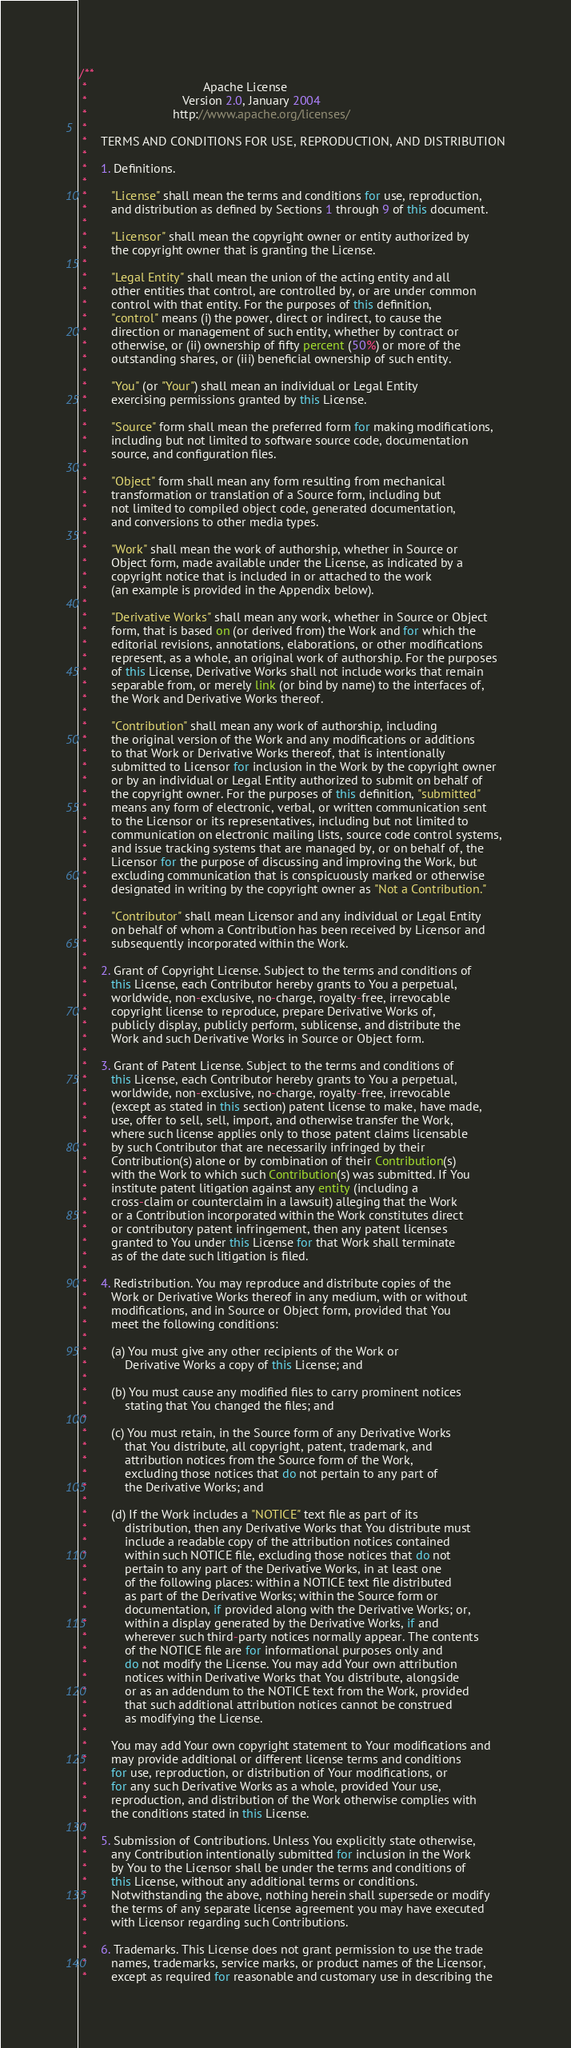Convert code to text. <code><loc_0><loc_0><loc_500><loc_500><_Java_>/**
 *                                  Apache License
 *                            Version 2.0, January 2004
 *                         http://www.apache.org/licenses/
 *
 *    TERMS AND CONDITIONS FOR USE, REPRODUCTION, AND DISTRIBUTION
 *
 *    1. Definitions.
 *
 *       "License" shall mean the terms and conditions for use, reproduction,
 *       and distribution as defined by Sections 1 through 9 of this document.
 *
 *       "Licensor" shall mean the copyright owner or entity authorized by
 *       the copyright owner that is granting the License.
 *
 *       "Legal Entity" shall mean the union of the acting entity and all
 *       other entities that control, are controlled by, or are under common
 *       control with that entity. For the purposes of this definition,
 *       "control" means (i) the power, direct or indirect, to cause the
 *       direction or management of such entity, whether by contract or
 *       otherwise, or (ii) ownership of fifty percent (50%) or more of the
 *       outstanding shares, or (iii) beneficial ownership of such entity.
 *
 *       "You" (or "Your") shall mean an individual or Legal Entity
 *       exercising permissions granted by this License.
 *
 *       "Source" form shall mean the preferred form for making modifications,
 *       including but not limited to software source code, documentation
 *       source, and configuration files.
 *
 *       "Object" form shall mean any form resulting from mechanical
 *       transformation or translation of a Source form, including but
 *       not limited to compiled object code, generated documentation,
 *       and conversions to other media types.
 *
 *       "Work" shall mean the work of authorship, whether in Source or
 *       Object form, made available under the License, as indicated by a
 *       copyright notice that is included in or attached to the work
 *       (an example is provided in the Appendix below).
 *
 *       "Derivative Works" shall mean any work, whether in Source or Object
 *       form, that is based on (or derived from) the Work and for which the
 *       editorial revisions, annotations, elaborations, or other modifications
 *       represent, as a whole, an original work of authorship. For the purposes
 *       of this License, Derivative Works shall not include works that remain
 *       separable from, or merely link (or bind by name) to the interfaces of,
 *       the Work and Derivative Works thereof.
 *
 *       "Contribution" shall mean any work of authorship, including
 *       the original version of the Work and any modifications or additions
 *       to that Work or Derivative Works thereof, that is intentionally
 *       submitted to Licensor for inclusion in the Work by the copyright owner
 *       or by an individual or Legal Entity authorized to submit on behalf of
 *       the copyright owner. For the purposes of this definition, "submitted"
 *       means any form of electronic, verbal, or written communication sent
 *       to the Licensor or its representatives, including but not limited to
 *       communication on electronic mailing lists, source code control systems,
 *       and issue tracking systems that are managed by, or on behalf of, the
 *       Licensor for the purpose of discussing and improving the Work, but
 *       excluding communication that is conspicuously marked or otherwise
 *       designated in writing by the copyright owner as "Not a Contribution."
 *
 *       "Contributor" shall mean Licensor and any individual or Legal Entity
 *       on behalf of whom a Contribution has been received by Licensor and
 *       subsequently incorporated within the Work.
 *
 *    2. Grant of Copyright License. Subject to the terms and conditions of
 *       this License, each Contributor hereby grants to You a perpetual,
 *       worldwide, non-exclusive, no-charge, royalty-free, irrevocable
 *       copyright license to reproduce, prepare Derivative Works of,
 *       publicly display, publicly perform, sublicense, and distribute the
 *       Work and such Derivative Works in Source or Object form.
 *
 *    3. Grant of Patent License. Subject to the terms and conditions of
 *       this License, each Contributor hereby grants to You a perpetual,
 *       worldwide, non-exclusive, no-charge, royalty-free, irrevocable
 *       (except as stated in this section) patent license to make, have made,
 *       use, offer to sell, sell, import, and otherwise transfer the Work,
 *       where such license applies only to those patent claims licensable
 *       by such Contributor that are necessarily infringed by their
 *       Contribution(s) alone or by combination of their Contribution(s)
 *       with the Work to which such Contribution(s) was submitted. If You
 *       institute patent litigation against any entity (including a
 *       cross-claim or counterclaim in a lawsuit) alleging that the Work
 *       or a Contribution incorporated within the Work constitutes direct
 *       or contributory patent infringement, then any patent licenses
 *       granted to You under this License for that Work shall terminate
 *       as of the date such litigation is filed.
 *
 *    4. Redistribution. You may reproduce and distribute copies of the
 *       Work or Derivative Works thereof in any medium, with or without
 *       modifications, and in Source or Object form, provided that You
 *       meet the following conditions:
 *
 *       (a) You must give any other recipients of the Work or
 *           Derivative Works a copy of this License; and
 *
 *       (b) You must cause any modified files to carry prominent notices
 *           stating that You changed the files; and
 *
 *       (c) You must retain, in the Source form of any Derivative Works
 *           that You distribute, all copyright, patent, trademark, and
 *           attribution notices from the Source form of the Work,
 *           excluding those notices that do not pertain to any part of
 *           the Derivative Works; and
 *
 *       (d) If the Work includes a "NOTICE" text file as part of its
 *           distribution, then any Derivative Works that You distribute must
 *           include a readable copy of the attribution notices contained
 *           within such NOTICE file, excluding those notices that do not
 *           pertain to any part of the Derivative Works, in at least one
 *           of the following places: within a NOTICE text file distributed
 *           as part of the Derivative Works; within the Source form or
 *           documentation, if provided along with the Derivative Works; or,
 *           within a display generated by the Derivative Works, if and
 *           wherever such third-party notices normally appear. The contents
 *           of the NOTICE file are for informational purposes only and
 *           do not modify the License. You may add Your own attribution
 *           notices within Derivative Works that You distribute, alongside
 *           or as an addendum to the NOTICE text from the Work, provided
 *           that such additional attribution notices cannot be construed
 *           as modifying the License.
 *
 *       You may add Your own copyright statement to Your modifications and
 *       may provide additional or different license terms and conditions
 *       for use, reproduction, or distribution of Your modifications, or
 *       for any such Derivative Works as a whole, provided Your use,
 *       reproduction, and distribution of the Work otherwise complies with
 *       the conditions stated in this License.
 *
 *    5. Submission of Contributions. Unless You explicitly state otherwise,
 *       any Contribution intentionally submitted for inclusion in the Work
 *       by You to the Licensor shall be under the terms and conditions of
 *       this License, without any additional terms or conditions.
 *       Notwithstanding the above, nothing herein shall supersede or modify
 *       the terms of any separate license agreement you may have executed
 *       with Licensor regarding such Contributions.
 *
 *    6. Trademarks. This License does not grant permission to use the trade
 *       names, trademarks, service marks, or product names of the Licensor,
 *       except as required for reasonable and customary use in describing the</code> 